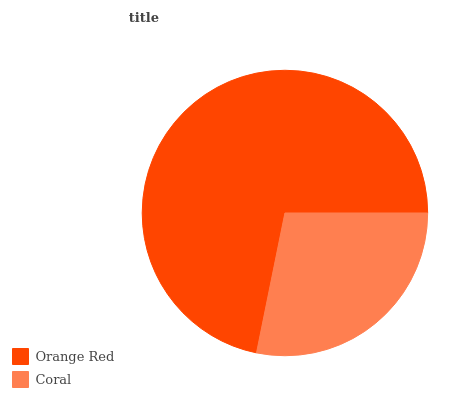Is Coral the minimum?
Answer yes or no. Yes. Is Orange Red the maximum?
Answer yes or no. Yes. Is Coral the maximum?
Answer yes or no. No. Is Orange Red greater than Coral?
Answer yes or no. Yes. Is Coral less than Orange Red?
Answer yes or no. Yes. Is Coral greater than Orange Red?
Answer yes or no. No. Is Orange Red less than Coral?
Answer yes or no. No. Is Orange Red the high median?
Answer yes or no. Yes. Is Coral the low median?
Answer yes or no. Yes. Is Coral the high median?
Answer yes or no. No. Is Orange Red the low median?
Answer yes or no. No. 